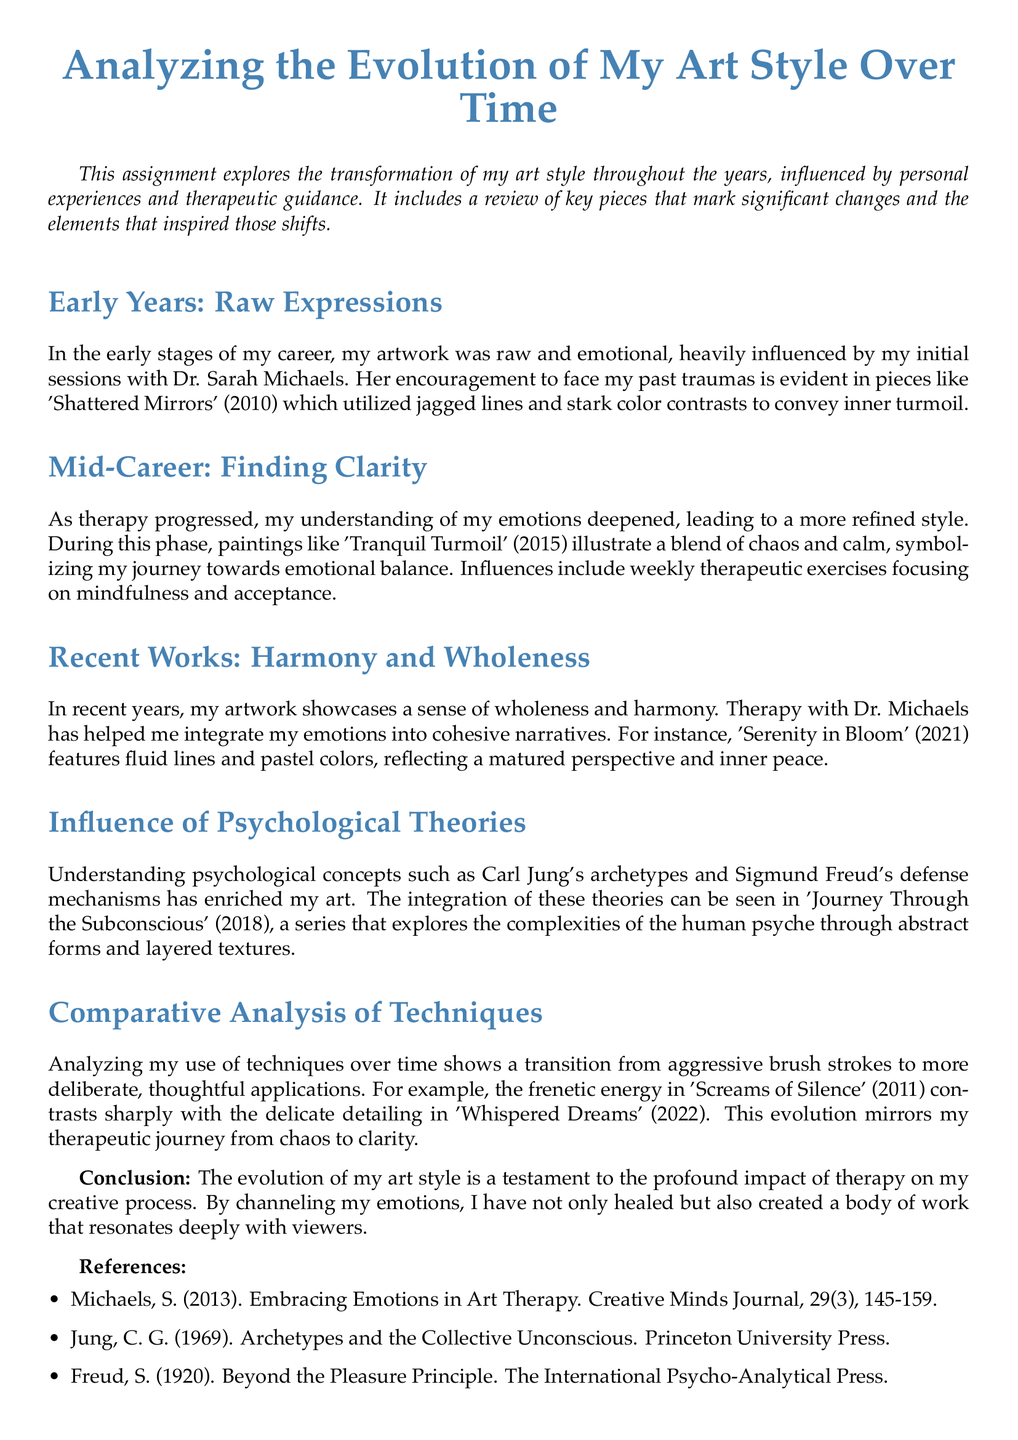What is the title of the document? The title of the document is stated at the beginning, highlighting the main subject of the work.
Answer: Analyzing the Evolution of My Art Style Over Time What year was 'Shattered Mirrors' created? The year of creation for 'Shattered Mirrors' is mentioned in the context of the early years of the artist's work.
Answer: 2010 Which psychological theories influenced the artist's work? The document specifies the psychological theories that have impacted the artist's creative process.
Answer: Carl Jung's archetypes and Sigmund Freud's defense mechanisms What is the main theme of 'Serenity in Bloom'? The document describes 'Serenity in Bloom' and the emotions it embodies, summarizing its visual style.
Answer: Inner peace How does the artist describe their early art style? The document provides insights into the feelings and characteristics of the artist's initial style.
Answer: Raw and emotional What major change occurred in the artist's mid-career style? The document indicates the shift towards a more refined style during the artist's mid-career phase.
Answer: More refined style In what year was 'Journey Through the Subconscious' created? The document clearly identifies the creation year for this specific series of artworks.
Answer: 2018 What painting contrasts with 'Whispered Dreams' in technique? The document refers to another painting that exemplifies a different technique from 'Whispered Dreams'.
Answer: Screams of Silence What was the impact of therapy on the artist's work? The document concludes by summarizing how therapy influenced the artist's creative output and emotional integration.
Answer: Profound impact 